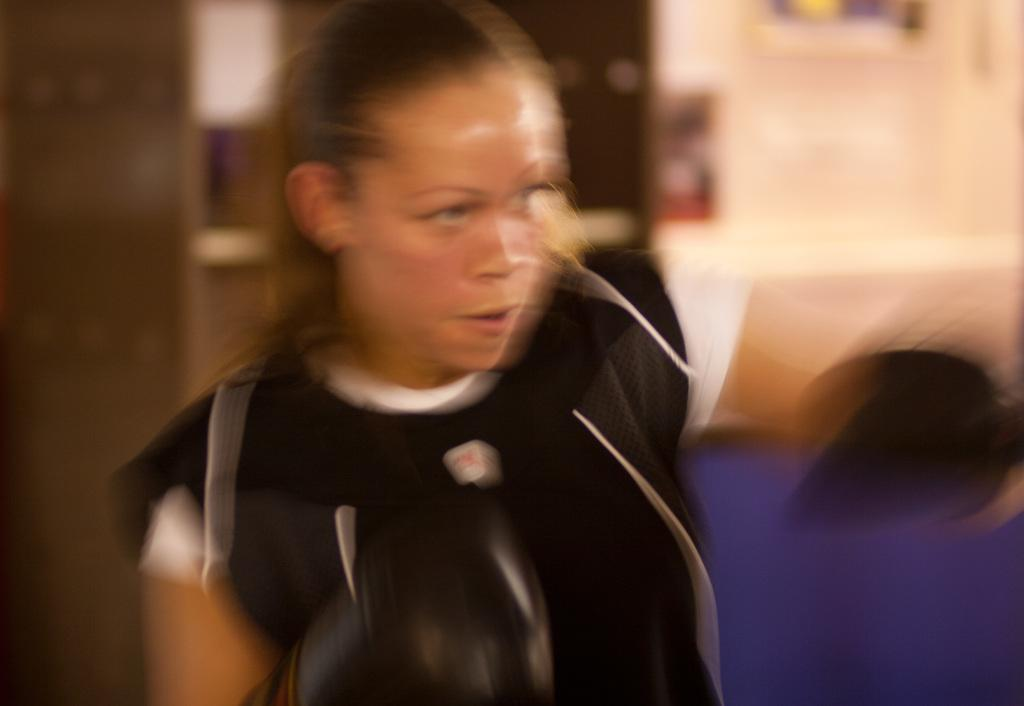Who is the main subject in the image? There is a woman in the image. Can you describe the background of the image? The background of the image is blurred. What type of yam is the woman holding in the image? There is no yam present in the image; the woman is the only subject visible. 